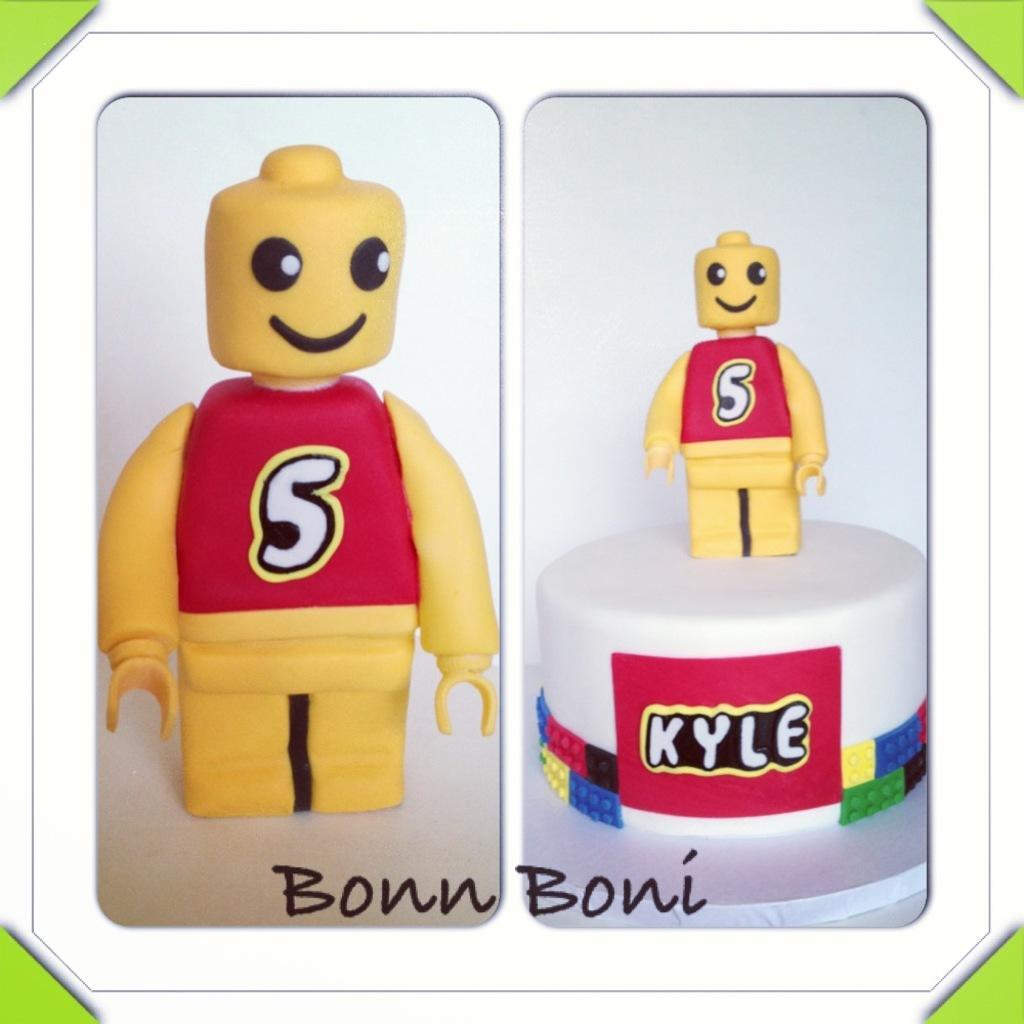How would you summarize this image in a sentence or two? This picture is the collage of two images. On the left side, we see a toy in yellow and red color. On the right side, we see a toy in yellow and red color is on the white color stool like structure. In the background, it is white in color. This picture is the photo frame. 